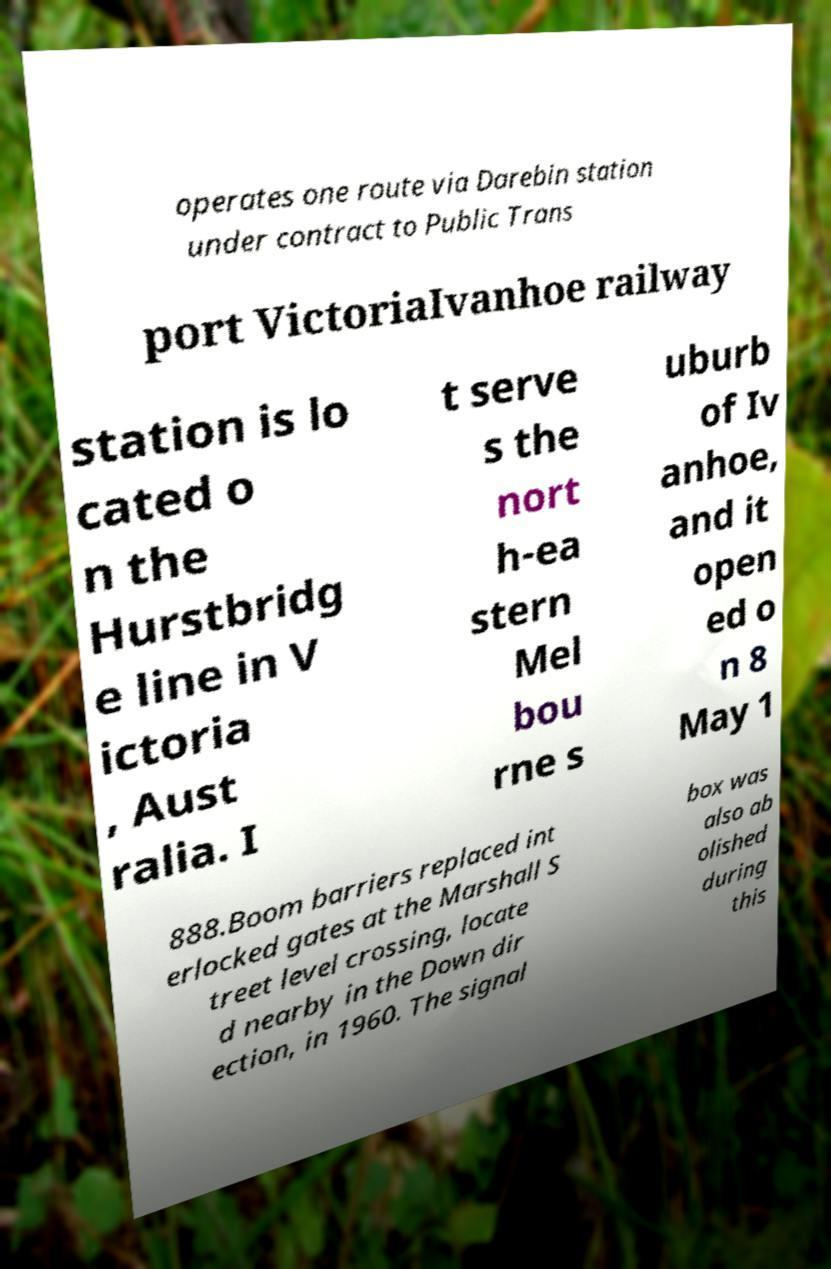I need the written content from this picture converted into text. Can you do that? operates one route via Darebin station under contract to Public Trans port VictoriaIvanhoe railway station is lo cated o n the Hurstbridg e line in V ictoria , Aust ralia. I t serve s the nort h-ea stern Mel bou rne s uburb of Iv anhoe, and it open ed o n 8 May 1 888.Boom barriers replaced int erlocked gates at the Marshall S treet level crossing, locate d nearby in the Down dir ection, in 1960. The signal box was also ab olished during this 